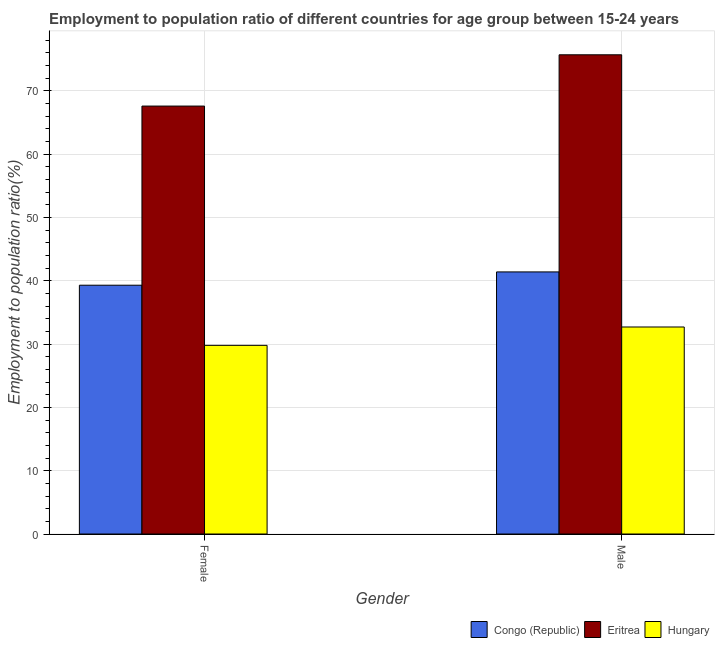How many groups of bars are there?
Your answer should be compact. 2. Are the number of bars per tick equal to the number of legend labels?
Provide a short and direct response. Yes. Are the number of bars on each tick of the X-axis equal?
Make the answer very short. Yes. How many bars are there on the 2nd tick from the right?
Your answer should be compact. 3. What is the label of the 2nd group of bars from the left?
Your response must be concise. Male. What is the employment to population ratio(male) in Congo (Republic)?
Give a very brief answer. 41.4. Across all countries, what is the maximum employment to population ratio(male)?
Provide a succinct answer. 75.7. Across all countries, what is the minimum employment to population ratio(male)?
Your response must be concise. 32.7. In which country was the employment to population ratio(male) maximum?
Provide a succinct answer. Eritrea. In which country was the employment to population ratio(male) minimum?
Keep it short and to the point. Hungary. What is the total employment to population ratio(female) in the graph?
Your answer should be compact. 136.7. What is the difference between the employment to population ratio(male) in Eritrea and that in Hungary?
Make the answer very short. 43. What is the difference between the employment to population ratio(female) in Hungary and the employment to population ratio(male) in Eritrea?
Your answer should be compact. -45.9. What is the average employment to population ratio(female) per country?
Offer a very short reply. 45.57. What is the difference between the employment to population ratio(female) and employment to population ratio(male) in Congo (Republic)?
Provide a succinct answer. -2.1. What is the ratio of the employment to population ratio(female) in Hungary to that in Congo (Republic)?
Your answer should be compact. 0.76. Is the employment to population ratio(male) in Eritrea less than that in Congo (Republic)?
Your answer should be very brief. No. In how many countries, is the employment to population ratio(male) greater than the average employment to population ratio(male) taken over all countries?
Give a very brief answer. 1. What does the 1st bar from the left in Female represents?
Provide a short and direct response. Congo (Republic). What does the 1st bar from the right in Female represents?
Your answer should be compact. Hungary. How many countries are there in the graph?
Your answer should be very brief. 3. What is the difference between two consecutive major ticks on the Y-axis?
Your answer should be very brief. 10. Does the graph contain any zero values?
Ensure brevity in your answer.  No. Where does the legend appear in the graph?
Your response must be concise. Bottom right. How many legend labels are there?
Your answer should be very brief. 3. How are the legend labels stacked?
Provide a succinct answer. Horizontal. What is the title of the graph?
Your answer should be compact. Employment to population ratio of different countries for age group between 15-24 years. Does "Morocco" appear as one of the legend labels in the graph?
Your answer should be compact. No. What is the label or title of the X-axis?
Make the answer very short. Gender. What is the label or title of the Y-axis?
Keep it short and to the point. Employment to population ratio(%). What is the Employment to population ratio(%) of Congo (Republic) in Female?
Provide a succinct answer. 39.3. What is the Employment to population ratio(%) of Eritrea in Female?
Your answer should be very brief. 67.6. What is the Employment to population ratio(%) in Hungary in Female?
Your answer should be very brief. 29.8. What is the Employment to population ratio(%) in Congo (Republic) in Male?
Make the answer very short. 41.4. What is the Employment to population ratio(%) in Eritrea in Male?
Your response must be concise. 75.7. What is the Employment to population ratio(%) of Hungary in Male?
Ensure brevity in your answer.  32.7. Across all Gender, what is the maximum Employment to population ratio(%) in Congo (Republic)?
Keep it short and to the point. 41.4. Across all Gender, what is the maximum Employment to population ratio(%) of Eritrea?
Give a very brief answer. 75.7. Across all Gender, what is the maximum Employment to population ratio(%) in Hungary?
Keep it short and to the point. 32.7. Across all Gender, what is the minimum Employment to population ratio(%) in Congo (Republic)?
Provide a short and direct response. 39.3. Across all Gender, what is the minimum Employment to population ratio(%) in Eritrea?
Your answer should be compact. 67.6. Across all Gender, what is the minimum Employment to population ratio(%) in Hungary?
Your answer should be very brief. 29.8. What is the total Employment to population ratio(%) in Congo (Republic) in the graph?
Your answer should be very brief. 80.7. What is the total Employment to population ratio(%) in Eritrea in the graph?
Your response must be concise. 143.3. What is the total Employment to population ratio(%) of Hungary in the graph?
Keep it short and to the point. 62.5. What is the difference between the Employment to population ratio(%) of Eritrea in Female and that in Male?
Your answer should be compact. -8.1. What is the difference between the Employment to population ratio(%) of Hungary in Female and that in Male?
Ensure brevity in your answer.  -2.9. What is the difference between the Employment to population ratio(%) in Congo (Republic) in Female and the Employment to population ratio(%) in Eritrea in Male?
Your response must be concise. -36.4. What is the difference between the Employment to population ratio(%) of Congo (Republic) in Female and the Employment to population ratio(%) of Hungary in Male?
Offer a very short reply. 6.6. What is the difference between the Employment to population ratio(%) in Eritrea in Female and the Employment to population ratio(%) in Hungary in Male?
Your response must be concise. 34.9. What is the average Employment to population ratio(%) of Congo (Republic) per Gender?
Ensure brevity in your answer.  40.35. What is the average Employment to population ratio(%) of Eritrea per Gender?
Give a very brief answer. 71.65. What is the average Employment to population ratio(%) of Hungary per Gender?
Provide a short and direct response. 31.25. What is the difference between the Employment to population ratio(%) of Congo (Republic) and Employment to population ratio(%) of Eritrea in Female?
Keep it short and to the point. -28.3. What is the difference between the Employment to population ratio(%) of Eritrea and Employment to population ratio(%) of Hungary in Female?
Provide a short and direct response. 37.8. What is the difference between the Employment to population ratio(%) of Congo (Republic) and Employment to population ratio(%) of Eritrea in Male?
Offer a very short reply. -34.3. What is the ratio of the Employment to population ratio(%) of Congo (Republic) in Female to that in Male?
Keep it short and to the point. 0.95. What is the ratio of the Employment to population ratio(%) of Eritrea in Female to that in Male?
Provide a succinct answer. 0.89. What is the ratio of the Employment to population ratio(%) of Hungary in Female to that in Male?
Offer a terse response. 0.91. What is the difference between the highest and the second highest Employment to population ratio(%) in Eritrea?
Your answer should be very brief. 8.1. What is the difference between the highest and the second highest Employment to population ratio(%) of Hungary?
Provide a succinct answer. 2.9. What is the difference between the highest and the lowest Employment to population ratio(%) in Congo (Republic)?
Make the answer very short. 2.1. What is the difference between the highest and the lowest Employment to population ratio(%) in Eritrea?
Offer a terse response. 8.1. 